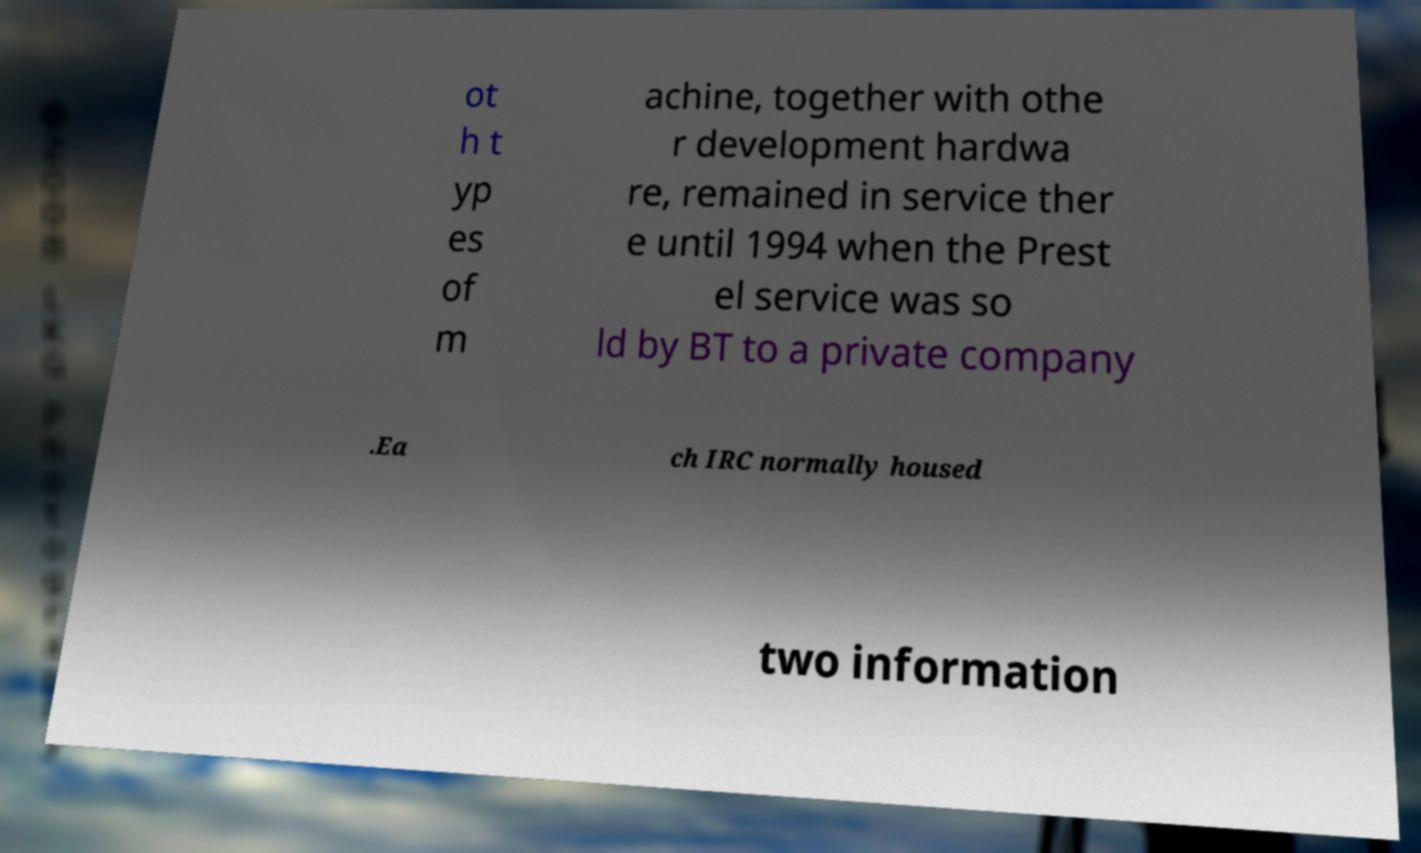For documentation purposes, I need the text within this image transcribed. Could you provide that? ot h t yp es of m achine, together with othe r development hardwa re, remained in service ther e until 1994 when the Prest el service was so ld by BT to a private company .Ea ch IRC normally housed two information 